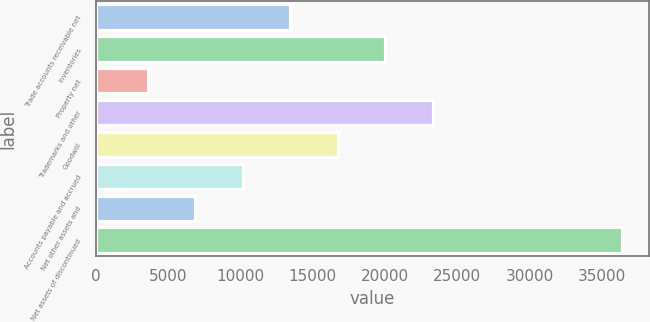Convert chart. <chart><loc_0><loc_0><loc_500><loc_500><bar_chart><fcel>Trade accounts receivable net<fcel>Inventories<fcel>Property net<fcel>Trademarks and other<fcel>Goodwill<fcel>Accounts payable and accrued<fcel>Net other assets and<fcel>Net assets of discontinued<nl><fcel>13470.3<fcel>20030.5<fcel>3630<fcel>23310.6<fcel>16750.4<fcel>10190.2<fcel>6910.1<fcel>36431<nl></chart> 